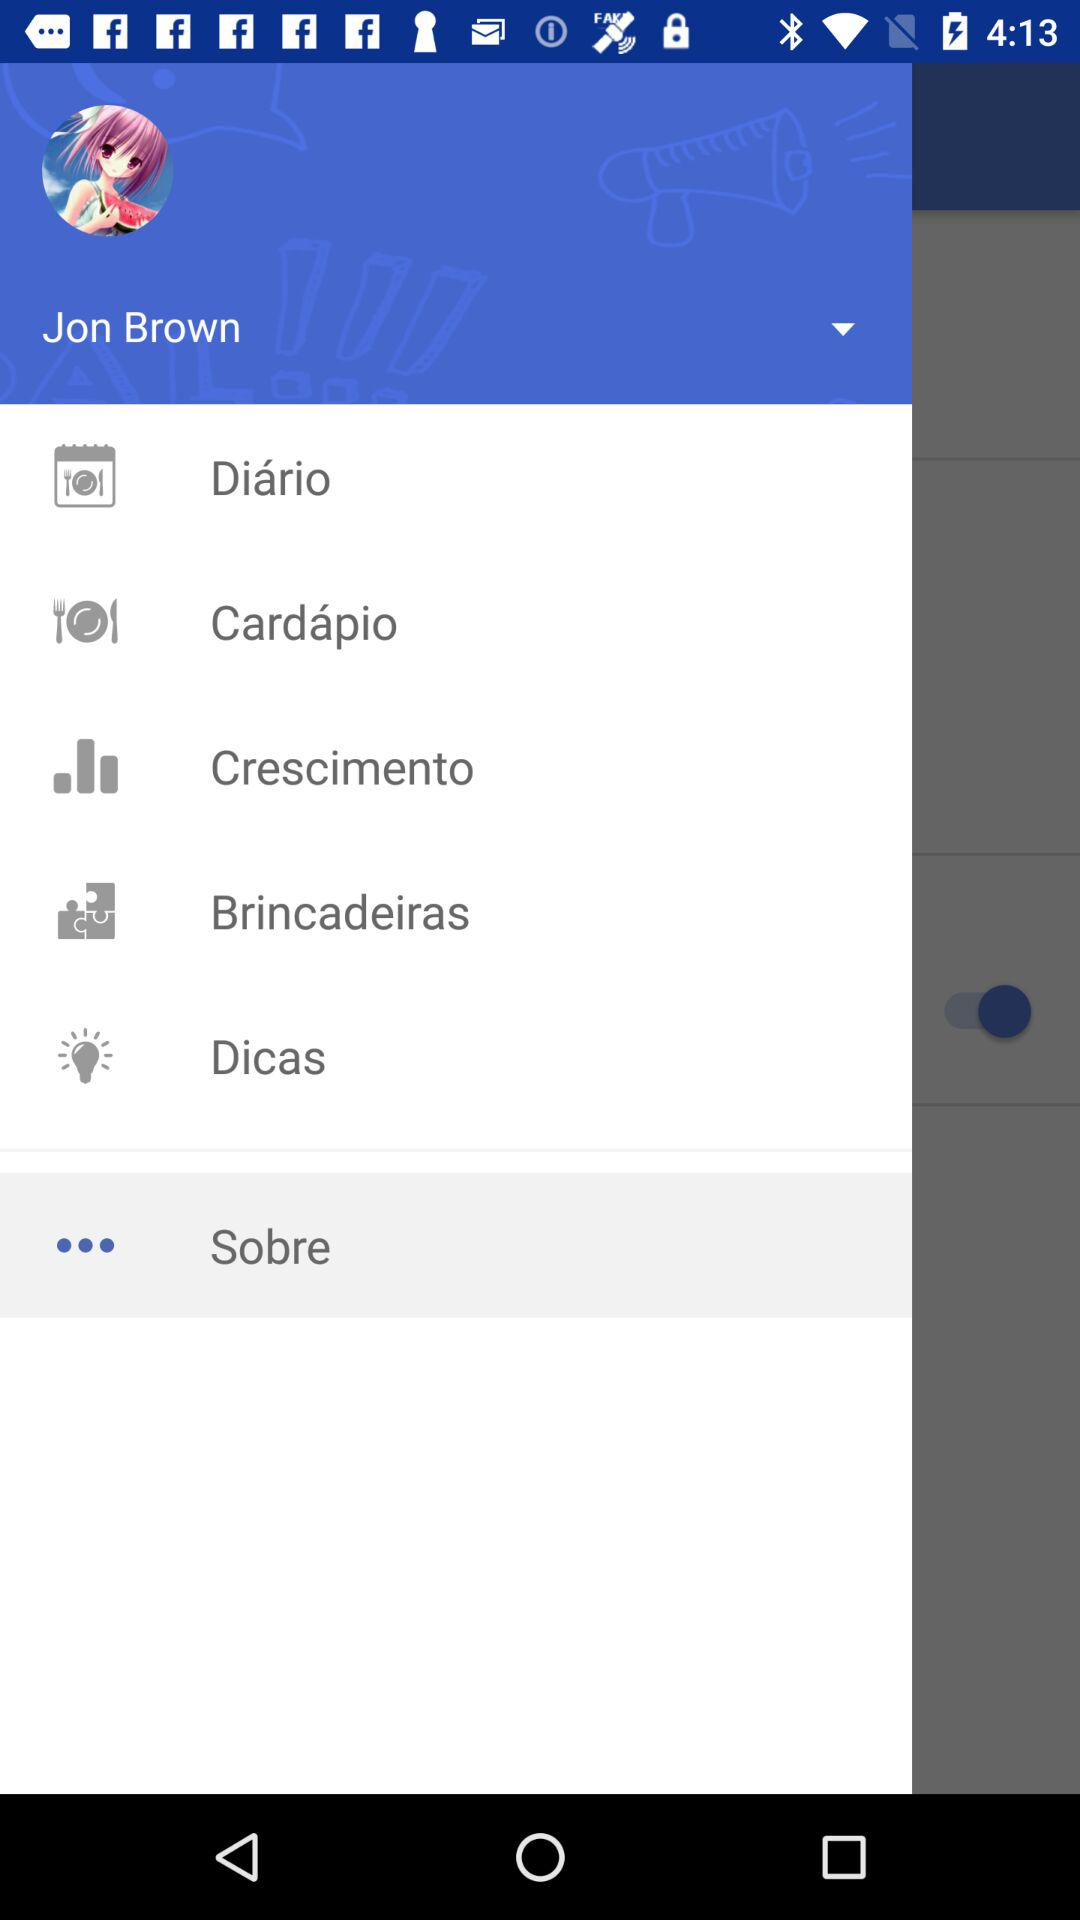What is the name of the user? The name of the user is Jon Brown. 